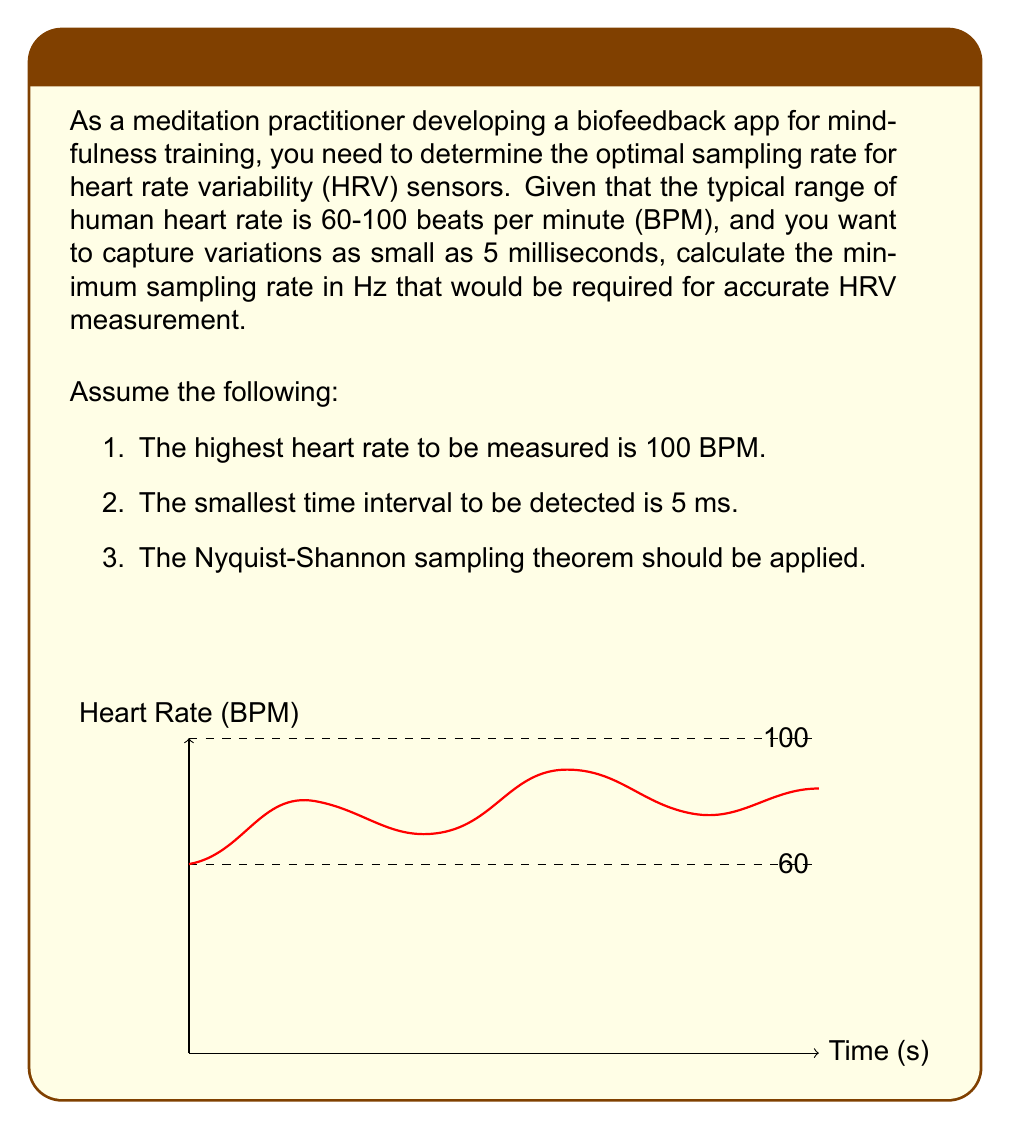Can you solve this math problem? To solve this problem, we'll follow these steps:

1) First, let's calculate the shortest possible R-R interval (time between heartbeats) at the maximum heart rate:

   At 100 BPM, the R-R interval is:
   $$T_{RR} = \frac{60 \text{ seconds}}{100 \text{ beats}} = 0.6 \text{ seconds}$$

2) Now, we need to determine how many samples are needed within this interval to detect a 5 ms variation:

   Number of samples = $\frac{0.6 \text{ s}}{0.005 \text{ s}} = 120$ samples

3) According to the Nyquist-Shannon sampling theorem, to accurately represent a signal, we need to sample at least twice the highest frequency component. In this case, we need at least 240 samples per R-R interval.

4) To convert this to a sampling rate in Hz, we divide by the R-R interval:

   $$f_s = \frac{240 \text{ samples}}{0.6 \text{ seconds}} = 400 \text{ Hz}$$

Therefore, the minimum sampling rate required is 400 Hz.

5) However, in practice, it's often recommended to oversample by a factor of 2-4 to account for non-ideal conditions. So a practical sampling rate might be:

   $$f_{practical} = 400 \text{ Hz} \times 2 = 800 \text{ Hz}$$
Answer: 400 Hz (theoretical minimum), 800 Hz (practical recommendation) 